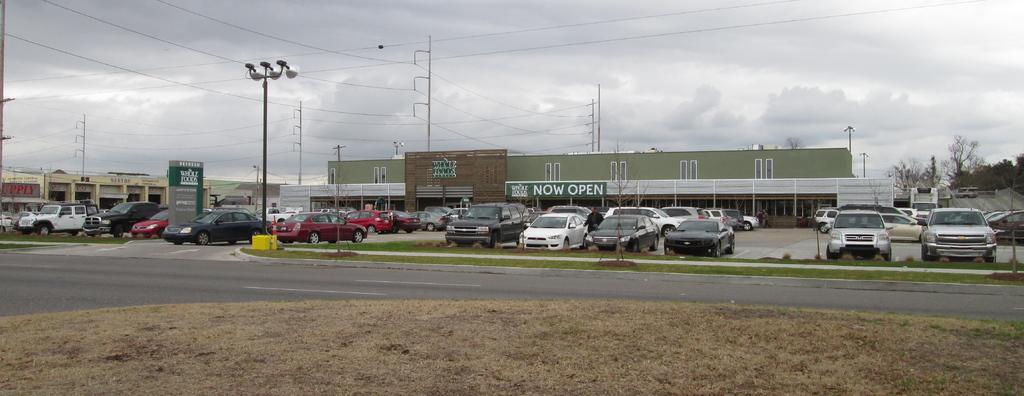<image>
Give a short and clear explanation of the subsequent image. A now open sign displayed on the side of Whole Foods. 